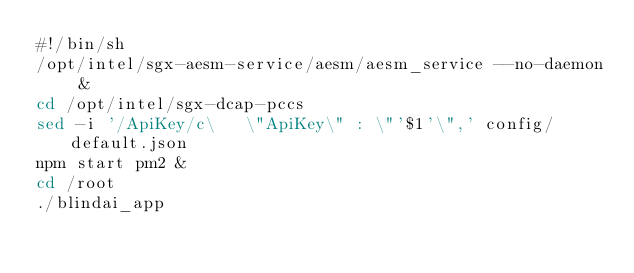Convert code to text. <code><loc_0><loc_0><loc_500><loc_500><_Bash_>#!/bin/sh
/opt/intel/sgx-aesm-service/aesm/aesm_service --no-daemon &
cd /opt/intel/sgx-dcap-pccs
sed -i '/ApiKey/c\   \"ApiKey\" : \"'$1'\",' config/default.json 
npm start pm2 & 
cd /root
./blindai_app
</code> 